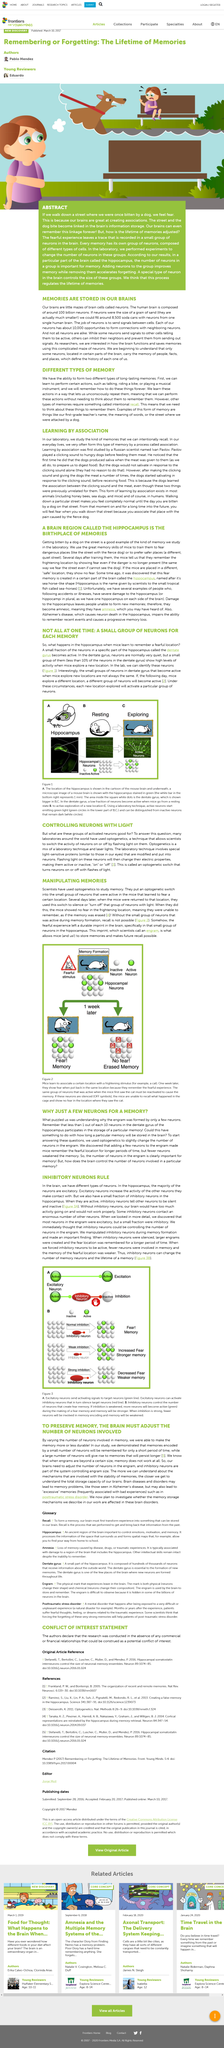Give some essential details in this illustration. Less than 10% of neurons exhibit high levels of activity when mice explore a new location," indicating that the majority of neurons remain relatively inactive during this behavioral process. The first type of long-lasting memory is the ability to learn and perform actions, such as talking, riding a bike, or playing a musical instrument, which are remembered permanently. The activity of neurons is switched on and off by the use of light. The title of this section is "Controlling Neurons with Light," which describes the use of light to manipulate the activity of neurons in the brain. Optogenetics is a technique that combines laboratory techniques and laser lights to manipulate the activity of cells in living organisms. 